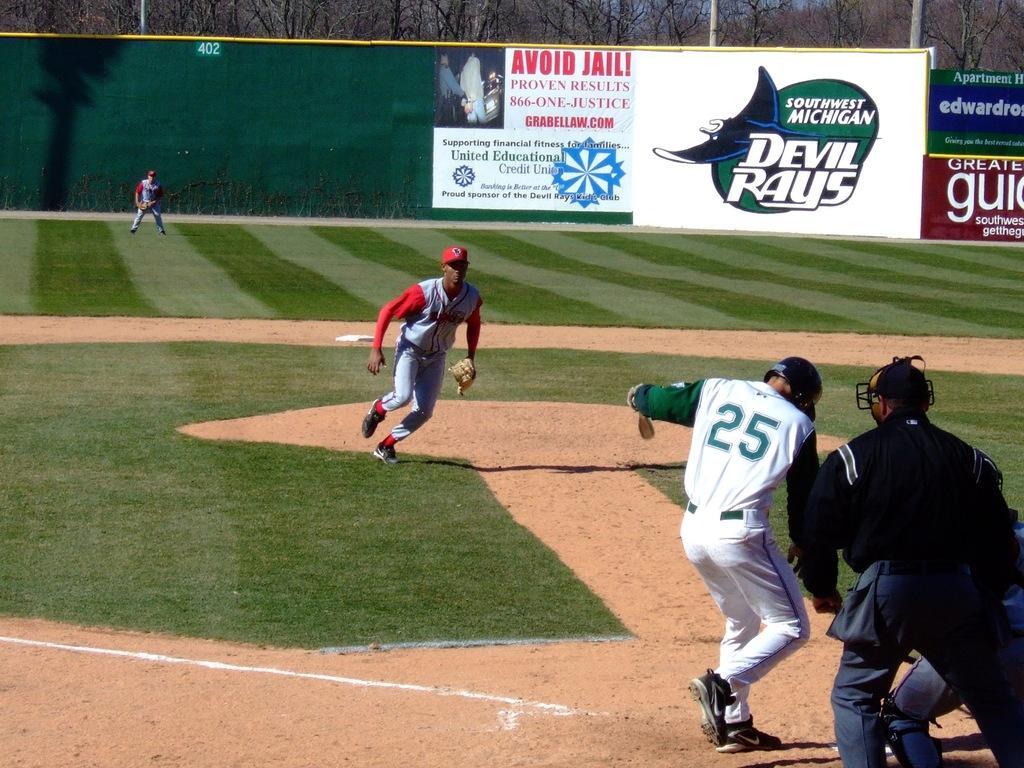Describe this image in one or two sentences. In this image I can see an open grass ground and on it I can see few people are playing baseball. I can also see all of the are wearing sports jerseys, gloves, caps and two of them are wearing helmets. I can also see something is written on their jerseys. In the background I can see few boards, number of trees, few poles, the sky and on these boards I can see something is written. 